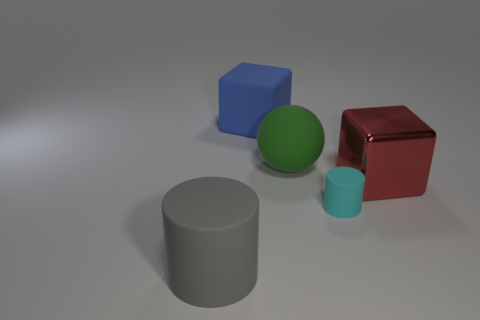Add 3 large gray metallic cylinders. How many objects exist? 8 Subtract all cylinders. How many objects are left? 3 Subtract 0 green blocks. How many objects are left? 5 Subtract all tiny purple objects. Subtract all large red things. How many objects are left? 4 Add 4 rubber blocks. How many rubber blocks are left? 5 Add 4 big brown rubber things. How many big brown rubber things exist? 4 